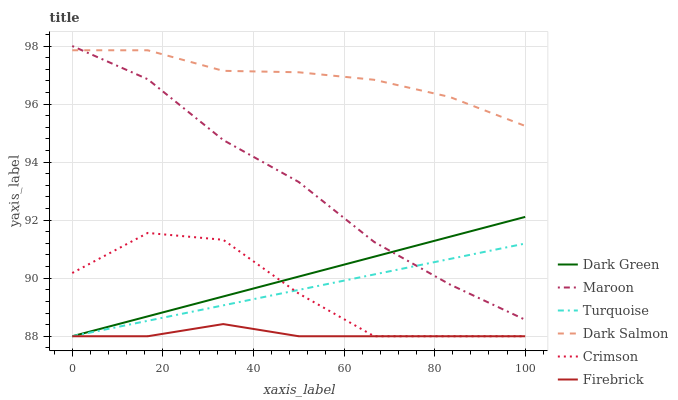Does Firebrick have the minimum area under the curve?
Answer yes or no. Yes. Does Dark Salmon have the maximum area under the curve?
Answer yes or no. Yes. Does Dark Salmon have the minimum area under the curve?
Answer yes or no. No. Does Firebrick have the maximum area under the curve?
Answer yes or no. No. Is Turquoise the smoothest?
Answer yes or no. Yes. Is Crimson the roughest?
Answer yes or no. Yes. Is Firebrick the smoothest?
Answer yes or no. No. Is Firebrick the roughest?
Answer yes or no. No. Does Turquoise have the lowest value?
Answer yes or no. Yes. Does Dark Salmon have the lowest value?
Answer yes or no. No. Does Maroon have the highest value?
Answer yes or no. Yes. Does Dark Salmon have the highest value?
Answer yes or no. No. Is Firebrick less than Dark Salmon?
Answer yes or no. Yes. Is Dark Salmon greater than Crimson?
Answer yes or no. Yes. Does Turquoise intersect Firebrick?
Answer yes or no. Yes. Is Turquoise less than Firebrick?
Answer yes or no. No. Is Turquoise greater than Firebrick?
Answer yes or no. No. Does Firebrick intersect Dark Salmon?
Answer yes or no. No. 